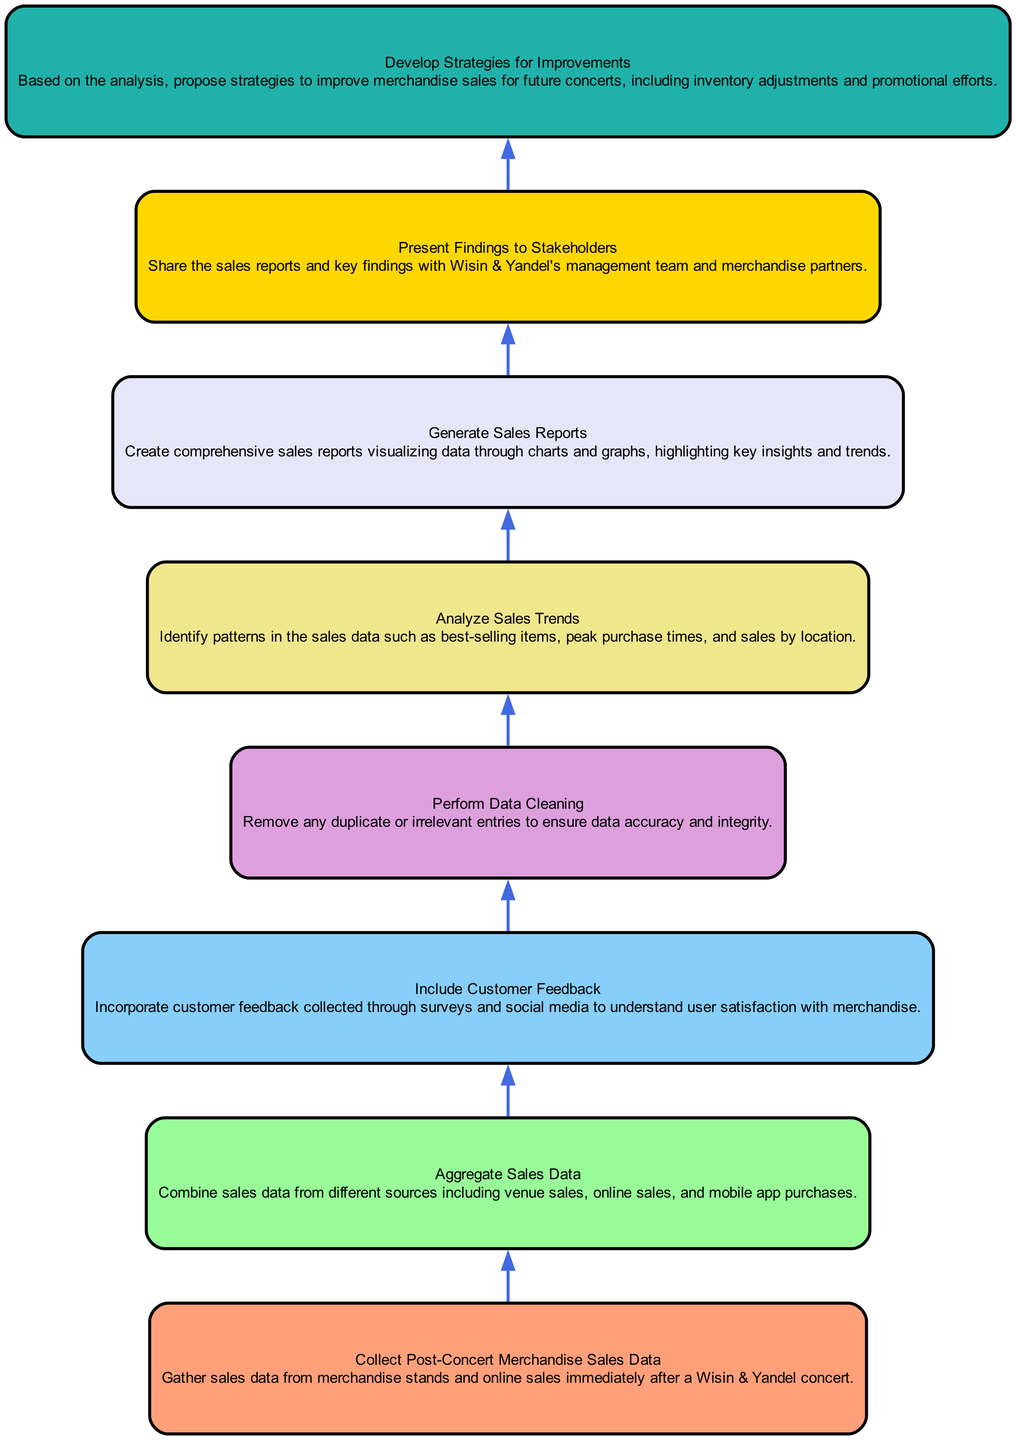What is the first step in the flow chart? The flow chart indicates that the first step is to collect post-concert merchandise sales data, as it is the initial node in the provided structure.
Answer: Collect Post-Concert Merchandise Sales Data How many nodes are there in the diagram? There are eight nodes listed in the diagram, corresponding to the eight steps of the sales analysis process, identified sequentially from collecting data to developing strategies.
Answer: Eight Which node comes after "Analyze Sales Trends"? The node that follows "Analyze Sales Trends" is "Generate Sales Reports," indicating that after analyzing the trends, reports are created based on the findings.
Answer: Generate Sales Reports What type of feedback is included in the analysis? The analysis includes customer feedback, which is collected through surveys and social media to assess user satisfaction regarding the merchandise purchased.
Answer: Customer feedback What step occurs before presenting findings to stakeholders? Before presenting findings to stakeholders, the last analysis step is to develop strategies for improvements based on the insights gathered from the sales data analysis.
Answer: Develop Strategies for Improvements Which node focuses on improving future sales? The node that focuses specifically on improving future sales is "Develop Strategies for Improvements," representing efforts to enhance merchandise sales for upcoming concerts.
Answer: Develop Strategies for Improvements Which two steps are directly connected in the diagram? The steps "Aggregate Sales Data" and "Include Customer Feedback" are directly connected as they both feed into the subsequent analysis stage that requires clean data from various sources and feedback.
Answer: Aggregate Sales Data and Include Customer Feedback What is the relationship between the "Perform Data Cleaning" node and the "Analyze Sales Trends"? The "Perform Data Cleaning" node must occur before the "Analyze Sales Trends" node, as data needs to be cleaned to ensure accuracy before any trend analysis can be conducted.
Answer: Data cleaning precedes analysis 